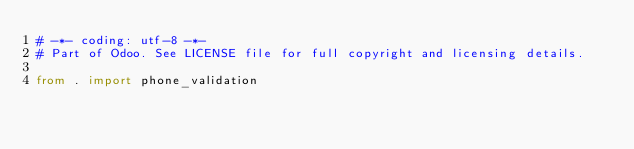<code> <loc_0><loc_0><loc_500><loc_500><_Python_># -*- coding: utf-8 -*-
# Part of Odoo. See LICENSE file for full copyright and licensing details.

from . import phone_validation
</code> 